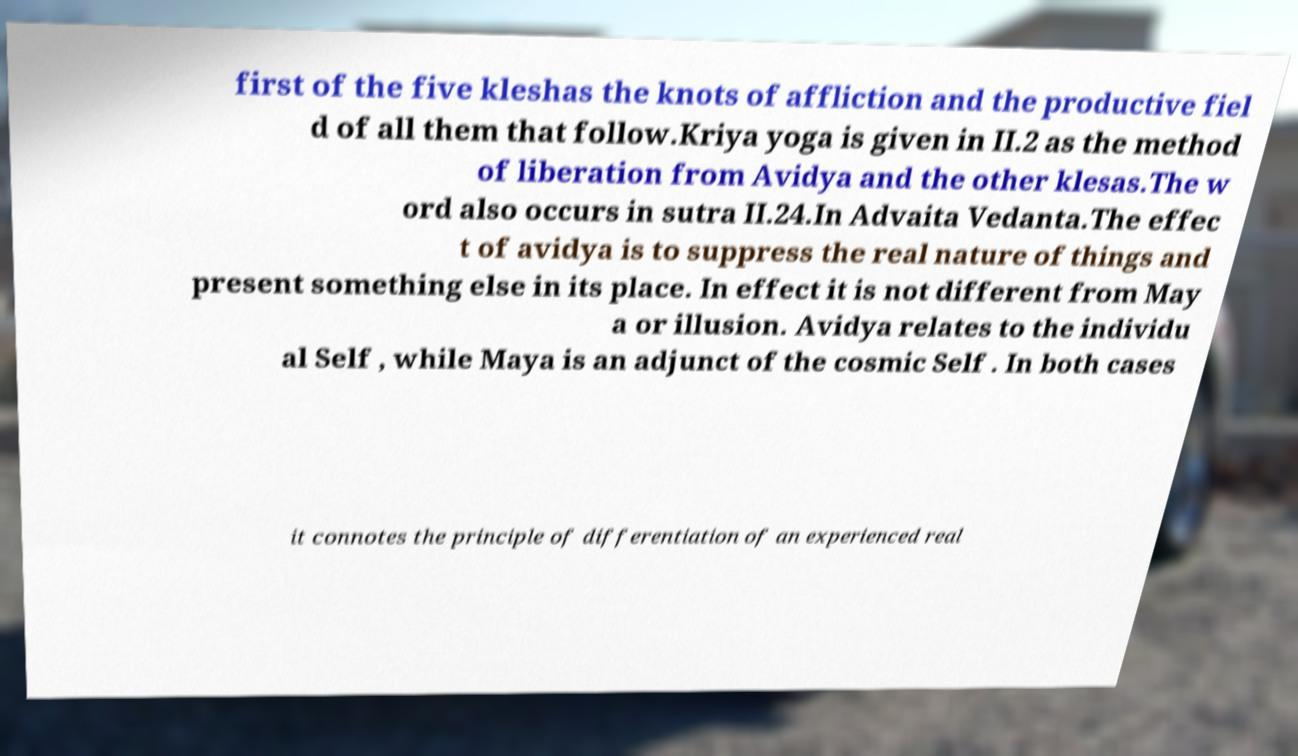What messages or text are displayed in this image? I need them in a readable, typed format. first of the five kleshas the knots of affliction and the productive fiel d of all them that follow.Kriya yoga is given in II.2 as the method of liberation from Avidya and the other klesas.The w ord also occurs in sutra II.24.In Advaita Vedanta.The effec t of avidya is to suppress the real nature of things and present something else in its place. In effect it is not different from May a or illusion. Avidya relates to the individu al Self , while Maya is an adjunct of the cosmic Self . In both cases it connotes the principle of differentiation of an experienced real 